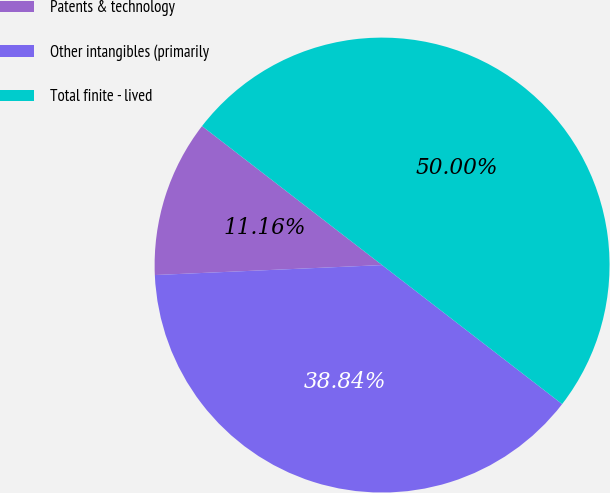Convert chart to OTSL. <chart><loc_0><loc_0><loc_500><loc_500><pie_chart><fcel>Patents & technology<fcel>Other intangibles (primarily<fcel>Total finite - lived<nl><fcel>11.16%<fcel>38.84%<fcel>50.0%<nl></chart> 